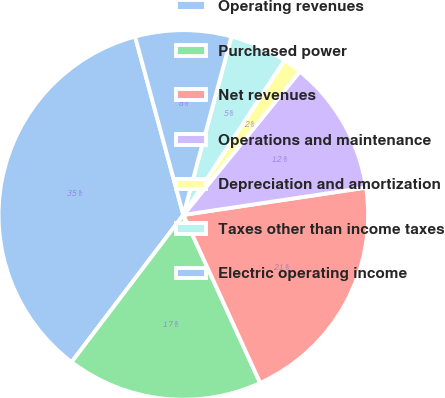Convert chart to OTSL. <chart><loc_0><loc_0><loc_500><loc_500><pie_chart><fcel>Operating revenues<fcel>Purchased power<fcel>Net revenues<fcel>Operations and maintenance<fcel>Depreciation and amortization<fcel>Taxes other than income taxes<fcel>Electric operating income<nl><fcel>35.45%<fcel>17.16%<fcel>20.54%<fcel>11.78%<fcel>1.64%<fcel>5.02%<fcel>8.4%<nl></chart> 